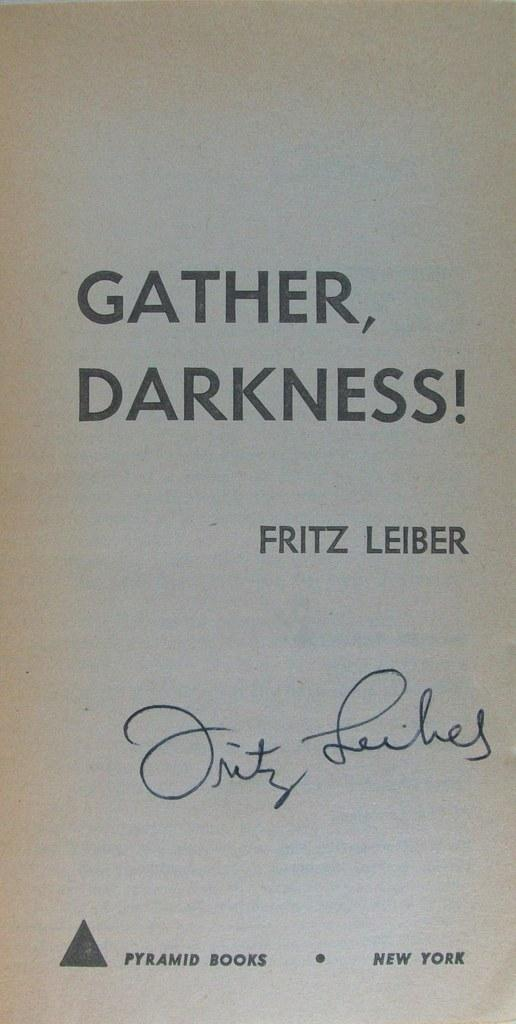<image>
Render a clear and concise summary of the photo. A book titled "Gather, Darkness!" by Fritz Leiber and signed by the author 